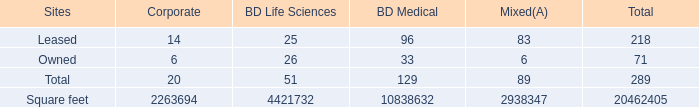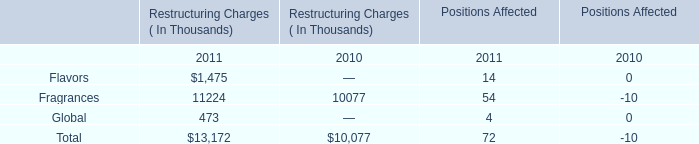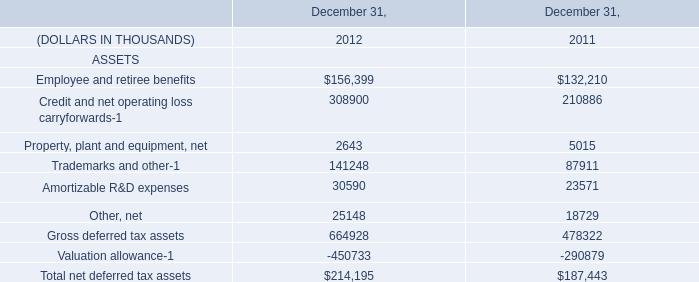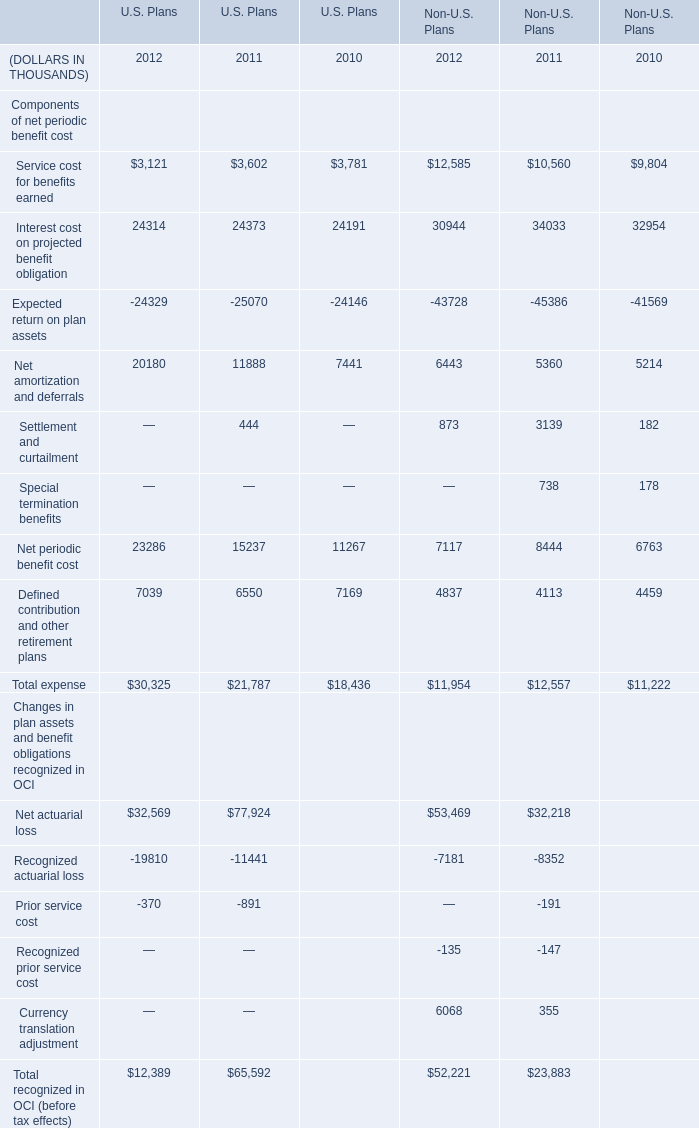What is the total amount of Employee and retiree benefits of December 31, 2011, Net periodic benefit cost of U.S. Plans 2012, and Defined contribution and other retirement plans of U.S. Plans 2012 ? 
Computations: ((132210.0 + 23286.0) + 7039.0)
Answer: 162535.0. 